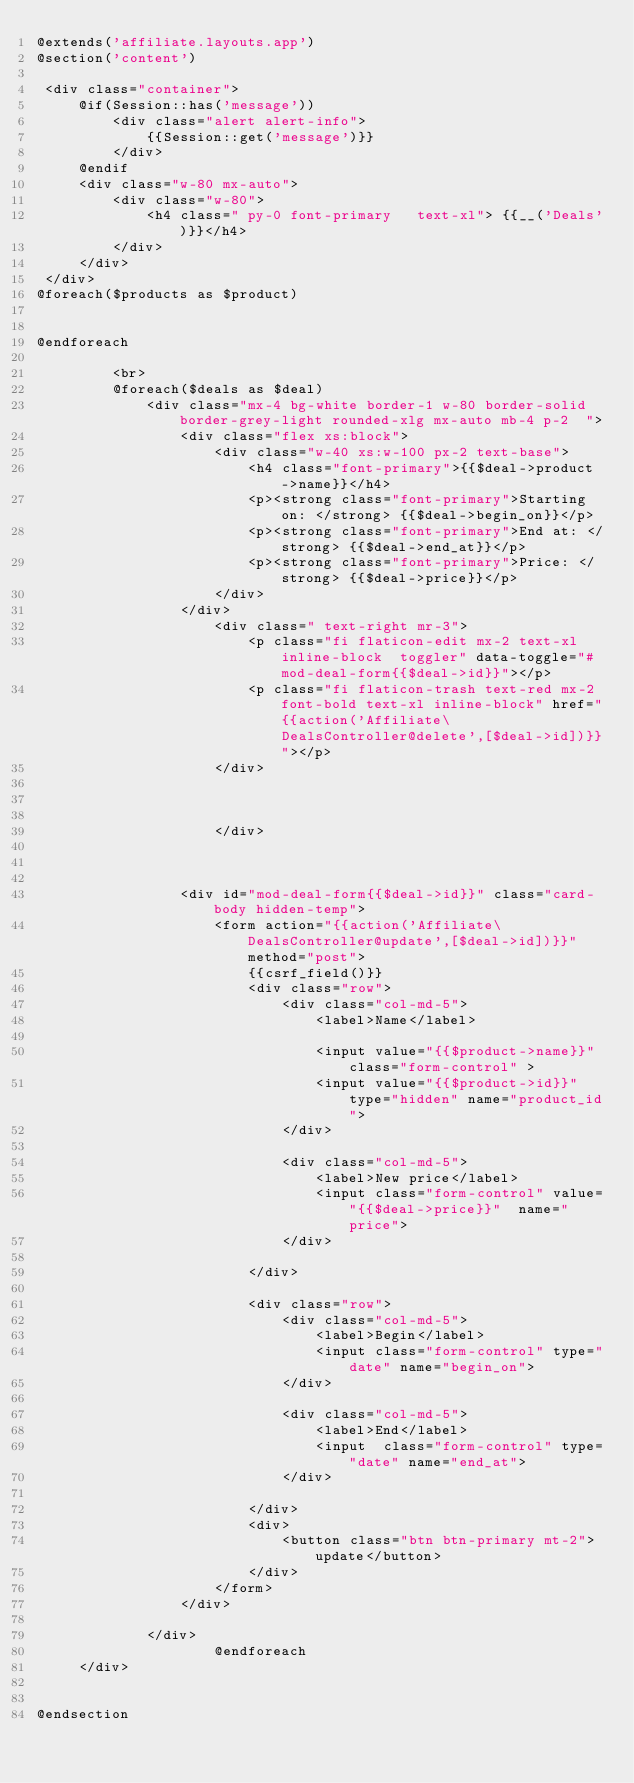Convert code to text. <code><loc_0><loc_0><loc_500><loc_500><_PHP_>@extends('affiliate.layouts.app')
@section('content')

 <div class="container">
     @if(Session::has('message'))
         <div class="alert alert-info">
             {{Session::get('message')}}
         </div>
     @endif
     <div class="w-80 mx-auto">
         <div class="w-80">
             <h4 class=" py-0 font-primary   text-xl"> {{__('Deals')}}</h4>
         </div>
     </div>
 </div>
@foreach($products as $product)


@endforeach

         <br>
         @foreach($deals as $deal)
             <div class="mx-4 bg-white border-1 w-80 border-solid border-grey-light rounded-xlg mx-auto mb-4 p-2  ">
                 <div class="flex xs:block">
                     <div class="w-40 xs:w-100 px-2 text-base">
                         <h4 class="font-primary">{{$deal->product->name}}</h4>
                         <p><strong class="font-primary">Starting on: </strong> {{$deal->begin_on}}</p>
                         <p><strong class="font-primary">End at: </strong> {{$deal->end_at}}</p>
                         <p><strong class="font-primary">Price: </strong> {{$deal->price}}</p>
                     </div>
                 </div>
                     <div class=" text-right mr-3">
                         <p class="fi flaticon-edit mx-2 text-xl inline-block  toggler" data-toggle="#mod-deal-form{{$deal->id}}"></p>
                         <p class="fi flaticon-trash text-red mx-2 font-bold text-xl inline-block" href="{{action('Affiliate\DealsController@delete',[$deal->id])}}"></p>
                     </div>



                     </div>



                 <div id="mod-deal-form{{$deal->id}}" class="card-body hidden-temp">
                     <form action="{{action('Affiliate\DealsController@update',[$deal->id])}}" method="post">
                         {{csrf_field()}}
                         <div class="row">
                             <div class="col-md-5">
                                 <label>Name</label>

                                 <input value="{{$product->name}}" class="form-control" >
                                 <input value="{{$product->id}}" type="hidden" name="product_id">
                             </div>

                             <div class="col-md-5">
                                 <label>New price</label>
                                 <input class="form-control" value="{{$deal->price}}"  name="price">
                             </div>

                         </div>

                         <div class="row">
                             <div class="col-md-5">
                                 <label>Begin</label>
                                 <input class="form-control" type="date" name="begin_on">
                             </div>

                             <div class="col-md-5">
                                 <label>End</label>
                                 <input  class="form-control" type="date" name="end_at">
                             </div>

                         </div>
                         <div>
                             <button class="btn btn-primary mt-2">update</button>
                         </div>
                     </form>
                 </div>

             </div>
                     @endforeach
     </div>


@endsection
</code> 